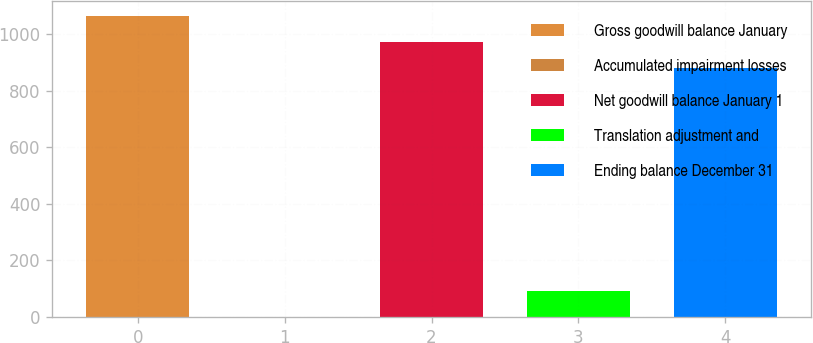Convert chart. <chart><loc_0><loc_0><loc_500><loc_500><bar_chart><fcel>Gross goodwill balance January<fcel>Accumulated impairment losses<fcel>Net goodwill balance January 1<fcel>Translation adjustment and<fcel>Ending balance December 31<nl><fcel>1064.26<fcel>0.2<fcel>972.13<fcel>92.33<fcel>880<nl></chart> 